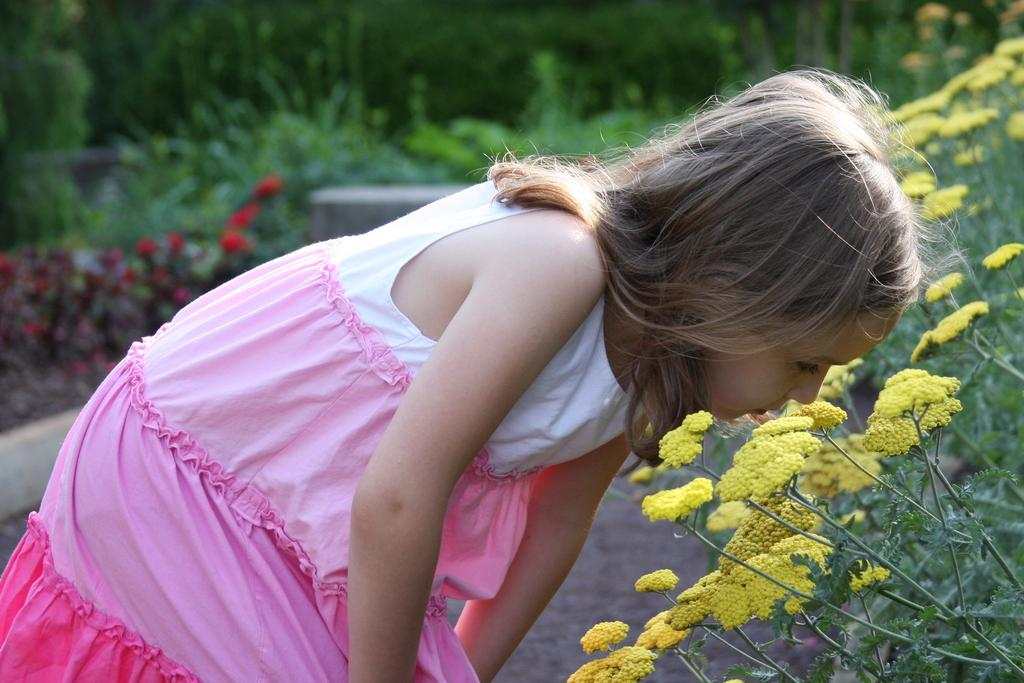Who is the main subject in the image? There is a girl in the image. What is the girl doing in the image? The girl is placing her head in front of a flower. What can be seen on the right side of the image? There are plants on the right side of the image. What type of vegetation is on the left side of the image? There are trees on the left side of the image. Can you hear the girl laughing in the image? The image is silent, so we cannot hear the girl laughing. What color is the stream in the image? There is no stream present in the image. 